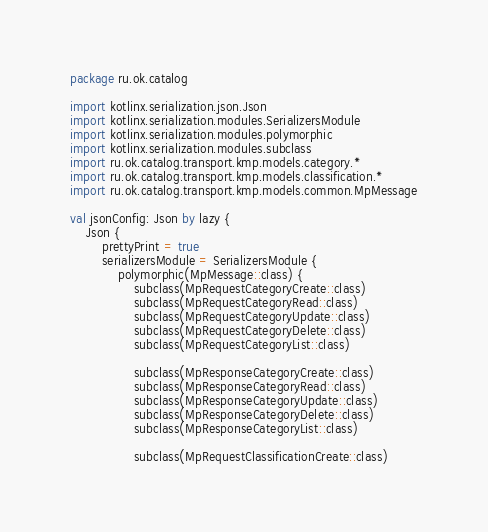<code> <loc_0><loc_0><loc_500><loc_500><_Kotlin_>package ru.ok.catalog

import kotlinx.serialization.json.Json
import kotlinx.serialization.modules.SerializersModule
import kotlinx.serialization.modules.polymorphic
import kotlinx.serialization.modules.subclass
import ru.ok.catalog.transport.kmp.models.category.*
import ru.ok.catalog.transport.kmp.models.classification.*
import ru.ok.catalog.transport.kmp.models.common.MpMessage

val jsonConfig: Json by lazy {
    Json {
        prettyPrint = true
        serializersModule = SerializersModule {
            polymorphic(MpMessage::class) {
                subclass(MpRequestCategoryCreate::class)
                subclass(MpRequestCategoryRead::class)
                subclass(MpRequestCategoryUpdate::class)
                subclass(MpRequestCategoryDelete::class)
                subclass(MpRequestCategoryList::class)

                subclass(MpResponseCategoryCreate::class)
                subclass(MpResponseCategoryRead::class)
                subclass(MpResponseCategoryUpdate::class)
                subclass(MpResponseCategoryDelete::class)
                subclass(MpResponseCategoryList::class)

                subclass(MpRequestClassificationCreate::class)</code> 